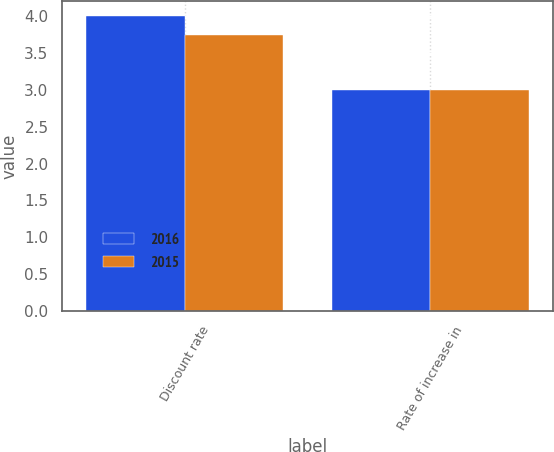<chart> <loc_0><loc_0><loc_500><loc_500><stacked_bar_chart><ecel><fcel>Discount rate<fcel>Rate of increase in<nl><fcel>2016<fcel>4<fcel>3<nl><fcel>2015<fcel>3.75<fcel>3<nl></chart> 